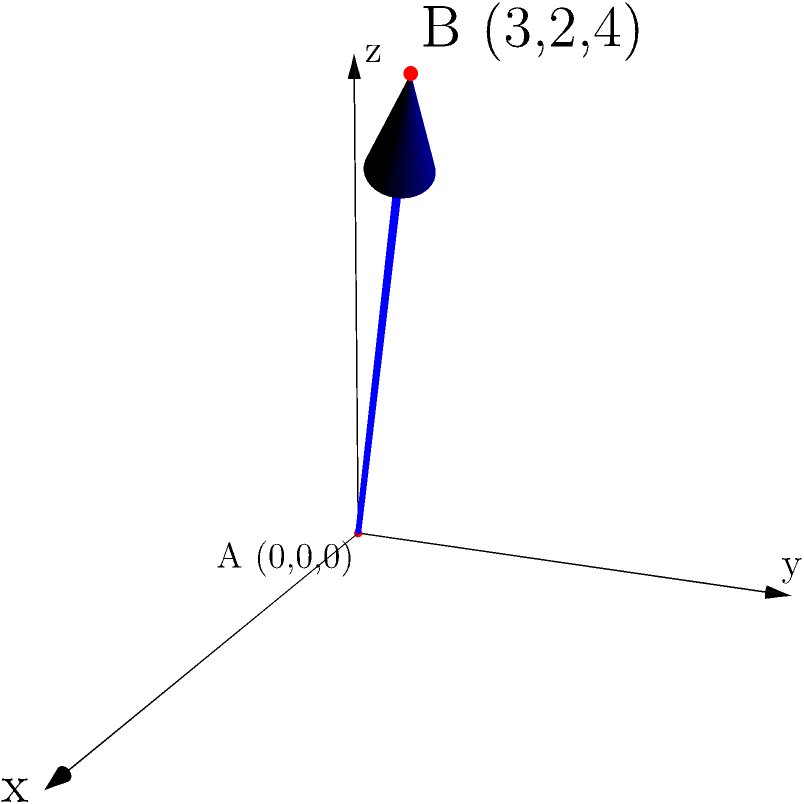In a recent case involving a shooting, you've been asked to analyze the bullet's trajectory. The bullet was fired from point A (0,0,0) and hit a target at point B (3,2,4) in a 3D coordinate system. What is the magnitude of the displacement vector of the bullet's path? To solve this problem, we'll follow these steps:

1) The displacement vector is the vector from point A to point B. We can calculate this by subtracting the coordinates of A from B.

   Displacement vector = B - A = (3-0, 2-0, 4-0) = (3, 2, 4)

2) To find the magnitude of this vector, we use the formula for the magnitude of a 3D vector:

   $\text{Magnitude} = \sqrt{x^2 + y^2 + z^2}$

3) Substituting our values:

   $\text{Magnitude} = \sqrt{3^2 + 2^2 + 4^2}$

4) Simplify:

   $\text{Magnitude} = \sqrt{9 + 4 + 16} = \sqrt{29}$

5) The square root of 29 cannot be simplified further, so we leave it as $\sqrt{29}$.

Therefore, the magnitude of the displacement vector is $\sqrt{29}$ units.
Answer: $\sqrt{29}$ units 